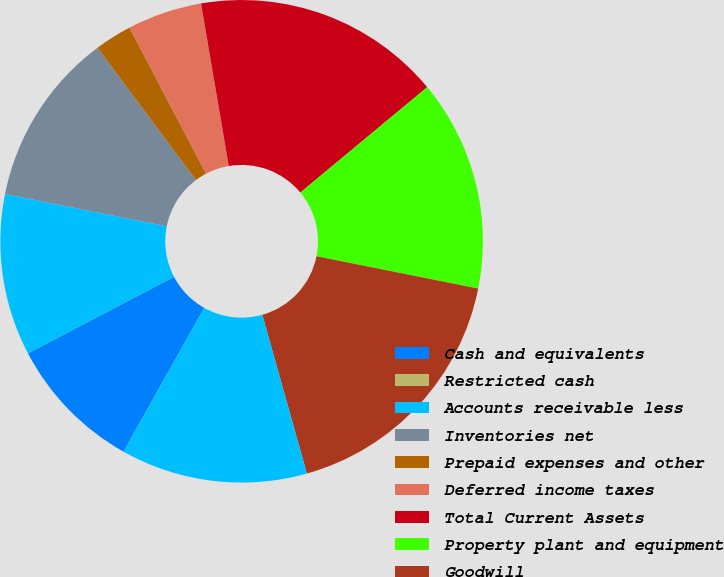Convert chart. <chart><loc_0><loc_0><loc_500><loc_500><pie_chart><fcel>Cash and equivalents<fcel>Restricted cash<fcel>Accounts receivable less<fcel>Inventories net<fcel>Prepaid expenses and other<fcel>Deferred income taxes<fcel>Total Current Assets<fcel>Property plant and equipment<fcel>Goodwill<fcel>Intangible assets net<nl><fcel>9.17%<fcel>0.0%<fcel>10.83%<fcel>11.67%<fcel>2.5%<fcel>5.0%<fcel>16.66%<fcel>14.17%<fcel>17.5%<fcel>12.5%<nl></chart> 